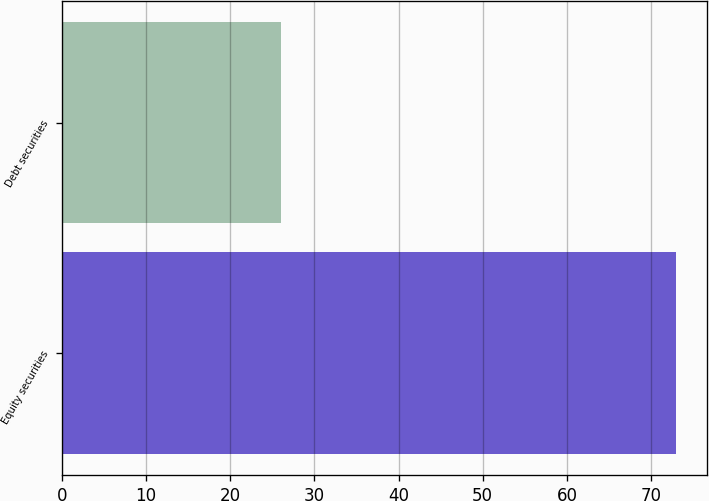<chart> <loc_0><loc_0><loc_500><loc_500><bar_chart><fcel>Equity securities<fcel>Debt securities<nl><fcel>73<fcel>26<nl></chart> 